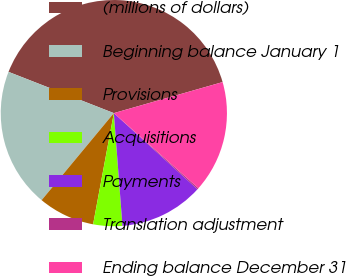Convert chart to OTSL. <chart><loc_0><loc_0><loc_500><loc_500><pie_chart><fcel>(millions of dollars)<fcel>Beginning balance January 1<fcel>Provisions<fcel>Acquisitions<fcel>Payments<fcel>Translation adjustment<fcel>Ending balance December 31<nl><fcel>39.64%<fcel>19.92%<fcel>8.09%<fcel>4.15%<fcel>12.03%<fcel>0.2%<fcel>15.98%<nl></chart> 